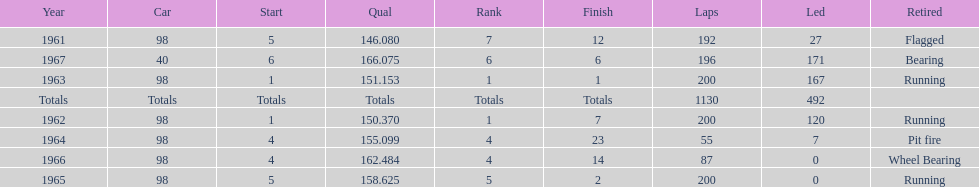How many total laps have been driven in the indy 500? 1130. 